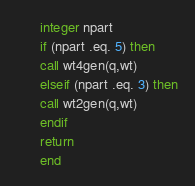<code> <loc_0><loc_0><loc_500><loc_500><_FORTRAN_>      integer npart
      if (npart .eq. 5) then
      call wt4gen(q,wt)
      elseif (npart .eq. 3) then
      call wt2gen(q,wt)
      endif
      return
      end
</code> 